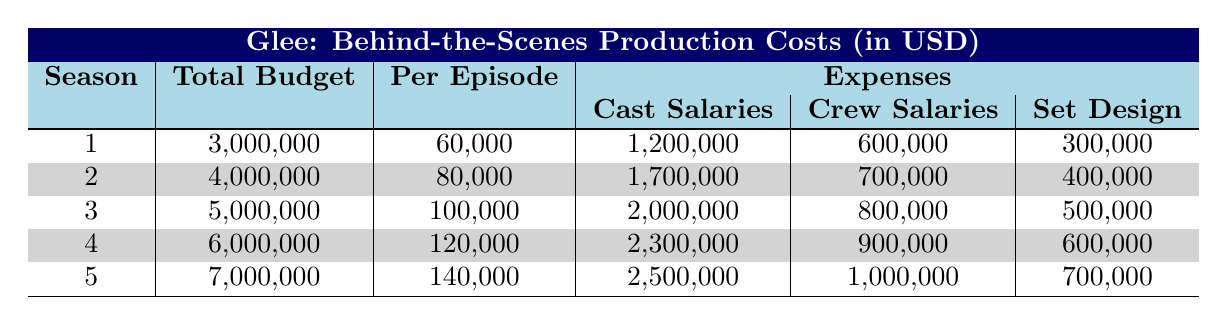What was the total budget for Season 2? The table indicates that the total budget for Season 2 is listed directly under the Total Budget column for that season, which shows 4,000,000.
Answer: 4,000,000 How much did cast salaries increase from Season 1 to Season 5? The cast salaries for Season 1 are 1,200,000 and for Season 5 are 2,500,000. To find the increase, subtract the Season 1 salaries from Season 5: 2,500,000 - 1,200,000 = 1,300,000.
Answer: 1,300,000 What is the average production cost per episode across all seasons? To calculate the average, sum the Per Episode costs (60,000 + 80,000 + 100,000 + 120,000 + 140,000 = 600,000), then divide by the number of seasons (5). So, 600,000 / 5 = 120,000.
Answer: 120,000 Did the total budget increase every season? By comparing the Total Budget values across all seasons, we see that they are 3,000,000, 4,000,000, 5,000,000, 6,000,000, and 7,000,000 respectively, which confirms that there was an increase each season.
Answer: Yes What was the total expense on music rights for all seasons combined? Add the music rights for each season together: 350,000 + 500,000 + 600,000 + 700,000 + 800,000 = 2,950,000.
Answer: 2,950,000 Which season had the highest expense for post-production? By inspecting the Post Production expenses in each season, Season 5 had the highest at 900,000, while others were lower.
Answer: Season 5 What percentage of the total budget in Season 4 was spent on cast salaries? The total budget for Season 4 is 6,000,000 and the cast salaries for that season is 2,300,000. To find the percentage, use (2,300,000 / 6,000,000) x 100, resulting in approximately 38.33%.
Answer: 38.33% How much more was spent on crew salaries in Season 3 compared to Season 1? Crew salaries in Season 3 are 800,000 and in Season 1 are 600,000. Subtract the two amounts: 800,000 - 600,000 = 200,000.
Answer: 200,000 What is the total cost of set design across all seasons? The costs for set design are 300,000 + 400,000 + 500,000 + 600,000 + 700,000, which sums to 2,500,000.
Answer: 2,500,000 Is the total budget for Season 5 more than 6 million? The total budget for Season 5 is 7,000,000, which is greater than 6 million.
Answer: Yes Which season had the highest total expense overall? By summing all expenses for each season (1,200,000 + 600,000 + 300,000 + 350,000 + 500,000 for Season 1, etc.), Season 5 has the highest total expense (totaling 5,250,000).
Answer: Season 5 